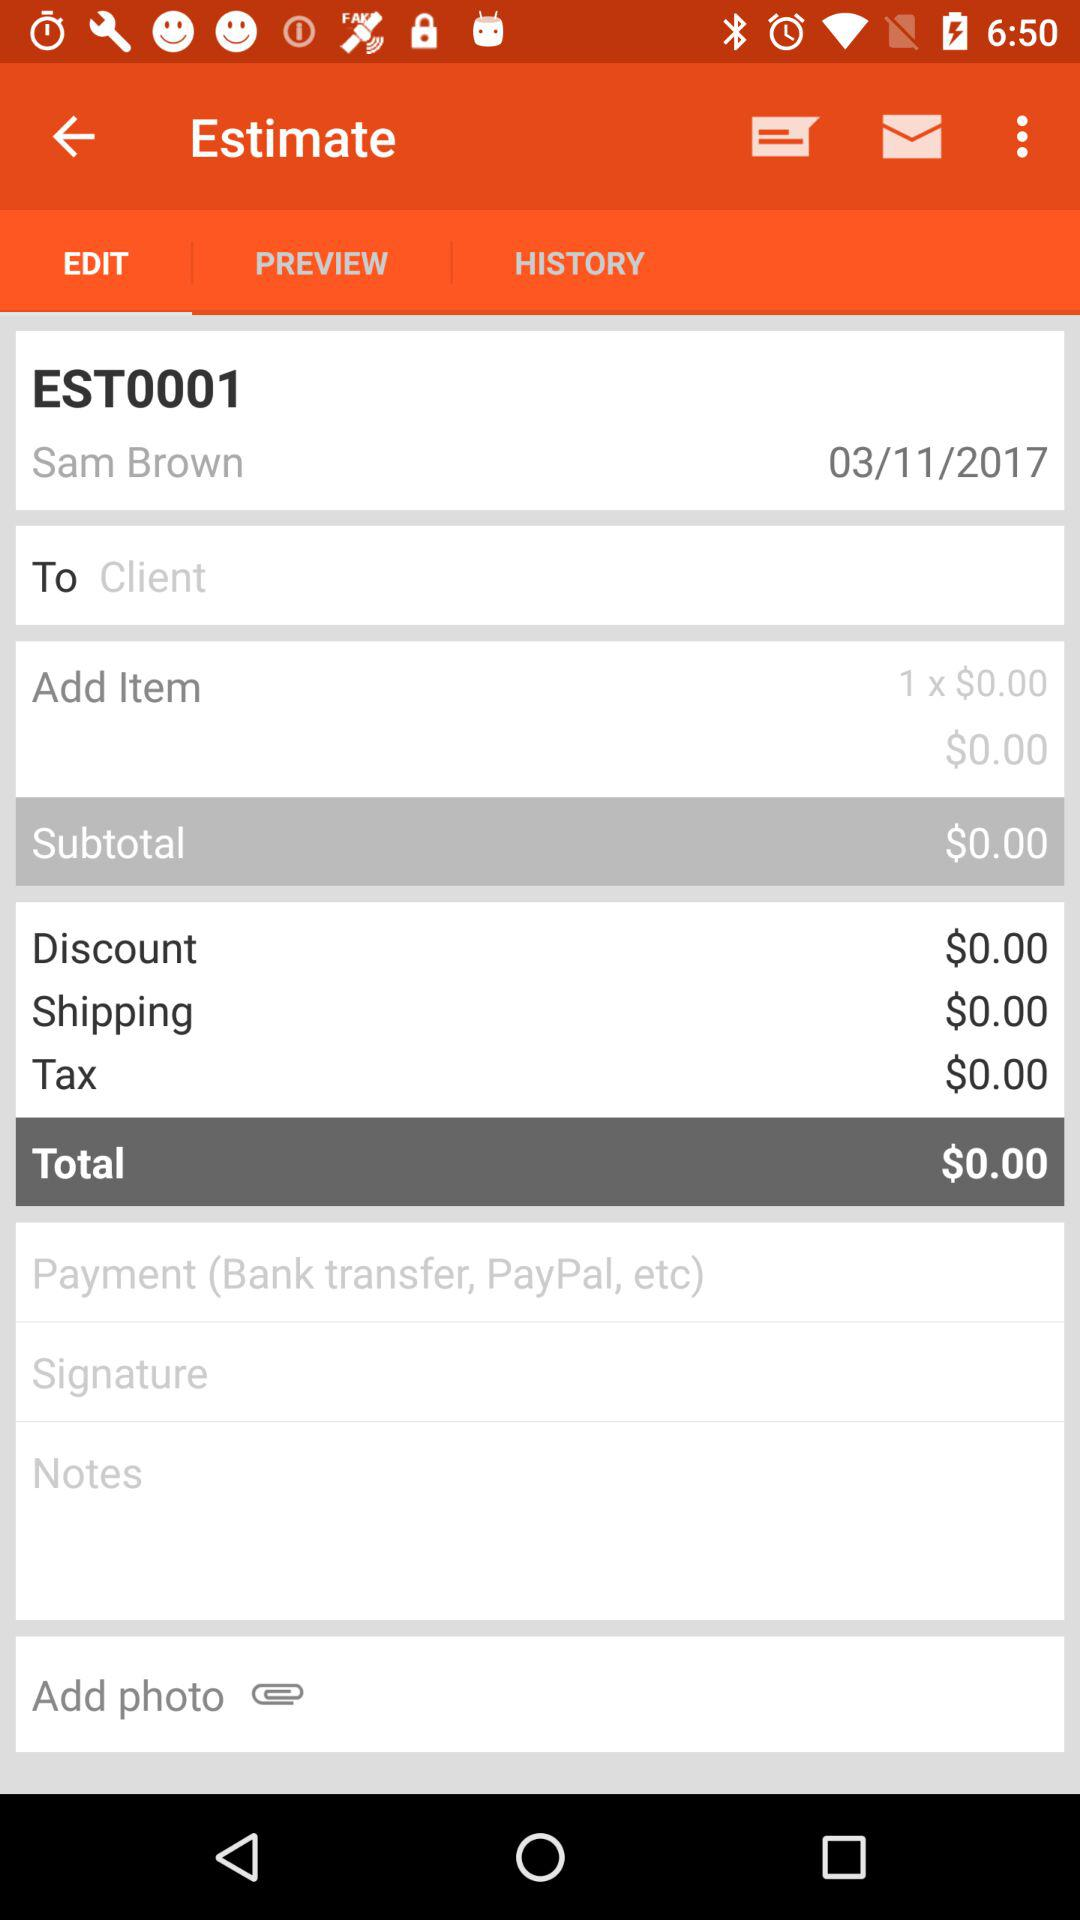What is the mentioned date? The mentioned date is March 11, 2017. 